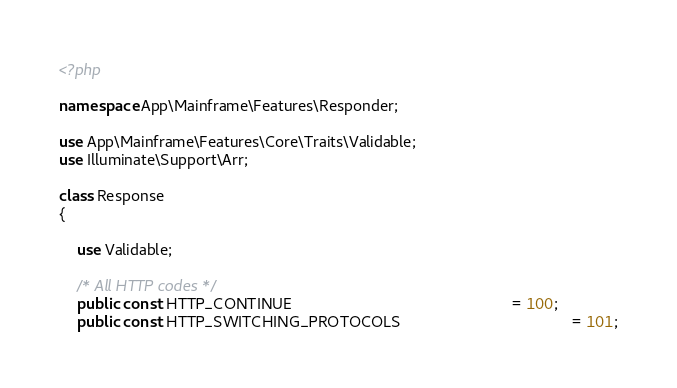<code> <loc_0><loc_0><loc_500><loc_500><_PHP_><?php

namespace App\Mainframe\Features\Responder;

use App\Mainframe\Features\Core\Traits\Validable;
use Illuminate\Support\Arr;

class Response
{

    use Validable;

    /* All HTTP codes */
    public const HTTP_CONTINUE                                                  = 100;
    public const HTTP_SWITCHING_PROTOCOLS                                       = 101;</code> 